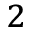Convert formula to latex. <formula><loc_0><loc_0><loc_500><loc_500>^ { 2 }</formula> 